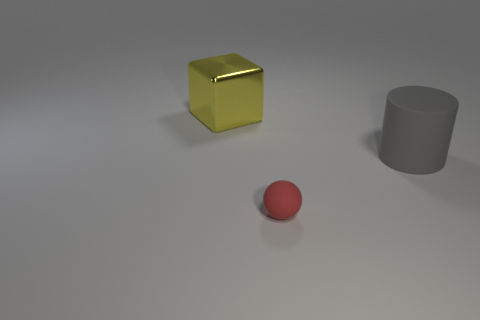What materials do the objects in the image appear to be made of? The yellow cube appears to have a glossy, perhaps metallic finish, while the grey cylindrical object looks like it could be matte ceramic or plastic. The red sphere seems to have a matte finish, consistent with a surface that scatters light diffusely. 